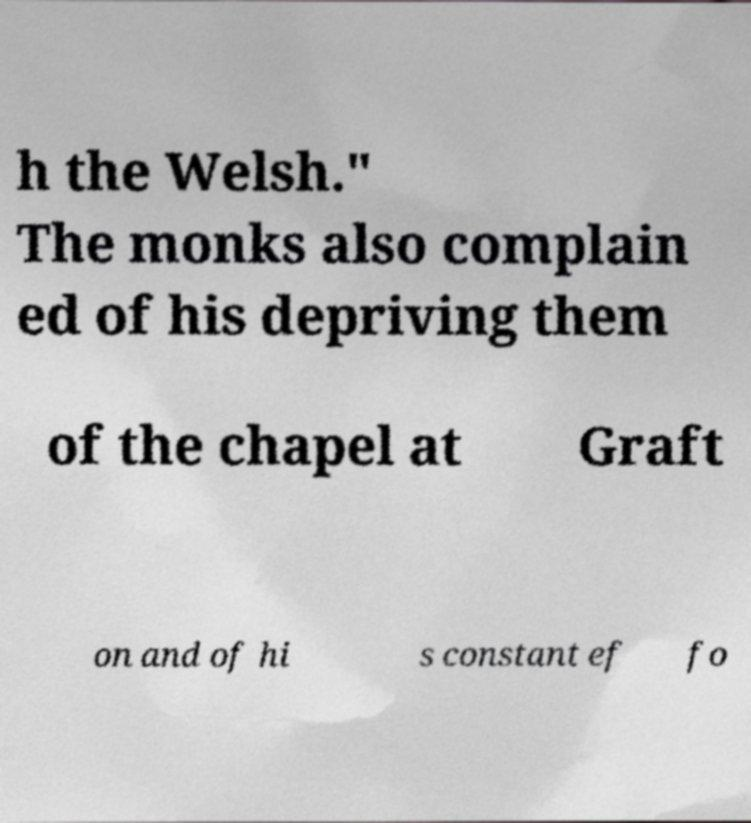Could you extract and type out the text from this image? h the Welsh." The monks also complain ed of his depriving them of the chapel at Graft on and of hi s constant ef fo 